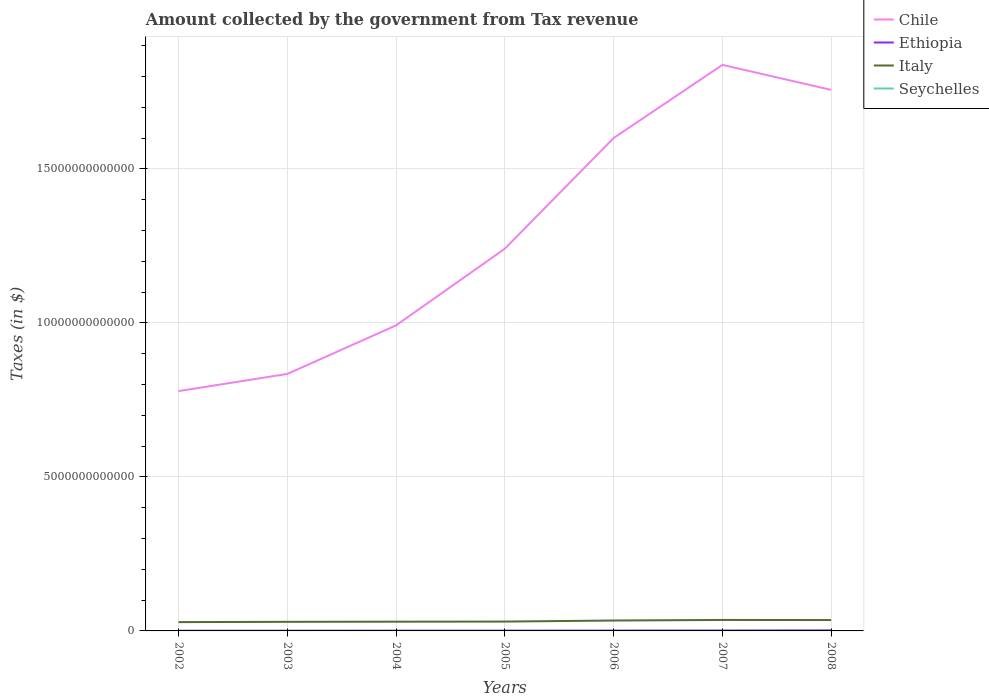How many different coloured lines are there?
Offer a terse response. 4. Does the line corresponding to Ethiopia intersect with the line corresponding to Chile?
Your response must be concise. No. Is the number of lines equal to the number of legend labels?
Provide a short and direct response. Yes. Across all years, what is the maximum amount collected by the government from tax revenue in Italy?
Your answer should be very brief. 2.86e+11. In which year was the amount collected by the government from tax revenue in Chile maximum?
Ensure brevity in your answer.  2002. What is the total amount collected by the government from tax revenue in Ethiopia in the graph?
Offer a terse response. -9.07e+08. What is the difference between the highest and the second highest amount collected by the government from tax revenue in Seychelles?
Provide a short and direct response. 1.05e+09. How many lines are there?
Provide a succinct answer. 4. How many years are there in the graph?
Make the answer very short. 7. What is the difference between two consecutive major ticks on the Y-axis?
Offer a very short reply. 5.00e+12. Are the values on the major ticks of Y-axis written in scientific E-notation?
Provide a short and direct response. No. Does the graph contain grids?
Make the answer very short. Yes. Where does the legend appear in the graph?
Your response must be concise. Top right. How are the legend labels stacked?
Your response must be concise. Vertical. What is the title of the graph?
Your response must be concise. Amount collected by the government from Tax revenue. What is the label or title of the Y-axis?
Keep it short and to the point. Taxes (in $). What is the Taxes (in $) in Chile in 2002?
Ensure brevity in your answer.  7.78e+12. What is the Taxes (in $) of Ethiopia in 2002?
Your answer should be compact. 6.51e+09. What is the Taxes (in $) in Italy in 2002?
Provide a succinct answer. 2.86e+11. What is the Taxes (in $) in Seychelles in 2002?
Make the answer very short. 9.99e+08. What is the Taxes (in $) in Chile in 2003?
Keep it short and to the point. 8.34e+12. What is the Taxes (in $) of Ethiopia in 2003?
Provide a succinct answer. 6.75e+09. What is the Taxes (in $) of Italy in 2003?
Your answer should be very brief. 2.95e+11. What is the Taxes (in $) in Seychelles in 2003?
Make the answer very short. 1.25e+09. What is the Taxes (in $) in Chile in 2004?
Keep it short and to the point. 9.92e+12. What is the Taxes (in $) in Ethiopia in 2004?
Offer a terse response. 8.45e+09. What is the Taxes (in $) of Italy in 2004?
Make the answer very short. 3.00e+11. What is the Taxes (in $) of Seychelles in 2004?
Make the answer very short. 1.36e+09. What is the Taxes (in $) of Chile in 2005?
Ensure brevity in your answer.  1.24e+13. What is the Taxes (in $) in Ethiopia in 2005?
Keep it short and to the point. 9.36e+09. What is the Taxes (in $) of Italy in 2005?
Offer a terse response. 3.03e+11. What is the Taxes (in $) in Seychelles in 2005?
Make the answer very short. 1.38e+09. What is the Taxes (in $) of Chile in 2006?
Provide a succinct answer. 1.60e+13. What is the Taxes (in $) in Ethiopia in 2006?
Your answer should be very brief. 1.10e+1. What is the Taxes (in $) of Italy in 2006?
Provide a short and direct response. 3.38e+11. What is the Taxes (in $) of Seychelles in 2006?
Your answer should be compact. 1.39e+09. What is the Taxes (in $) of Chile in 2007?
Provide a short and direct response. 1.84e+13. What is the Taxes (in $) of Ethiopia in 2007?
Ensure brevity in your answer.  1.35e+1. What is the Taxes (in $) of Italy in 2007?
Offer a terse response. 3.56e+11. What is the Taxes (in $) of Seychelles in 2007?
Offer a very short reply. 1.61e+09. What is the Taxes (in $) in Chile in 2008?
Keep it short and to the point. 1.76e+13. What is the Taxes (in $) of Ethiopia in 2008?
Offer a very short reply. 1.96e+1. What is the Taxes (in $) in Italy in 2008?
Your response must be concise. 3.53e+11. What is the Taxes (in $) in Seychelles in 2008?
Keep it short and to the point. 2.05e+09. Across all years, what is the maximum Taxes (in $) in Chile?
Your response must be concise. 1.84e+13. Across all years, what is the maximum Taxes (in $) of Ethiopia?
Provide a short and direct response. 1.96e+1. Across all years, what is the maximum Taxes (in $) in Italy?
Your answer should be compact. 3.56e+11. Across all years, what is the maximum Taxes (in $) in Seychelles?
Your answer should be compact. 2.05e+09. Across all years, what is the minimum Taxes (in $) in Chile?
Give a very brief answer. 7.78e+12. Across all years, what is the minimum Taxes (in $) of Ethiopia?
Give a very brief answer. 6.51e+09. Across all years, what is the minimum Taxes (in $) of Italy?
Offer a very short reply. 2.86e+11. Across all years, what is the minimum Taxes (in $) of Seychelles?
Your answer should be compact. 9.99e+08. What is the total Taxes (in $) of Chile in the graph?
Provide a short and direct response. 9.04e+13. What is the total Taxes (in $) in Ethiopia in the graph?
Your response must be concise. 7.51e+1. What is the total Taxes (in $) in Italy in the graph?
Make the answer very short. 2.23e+12. What is the total Taxes (in $) of Seychelles in the graph?
Ensure brevity in your answer.  1.00e+1. What is the difference between the Taxes (in $) in Chile in 2002 and that in 2003?
Offer a very short reply. -5.57e+11. What is the difference between the Taxes (in $) in Ethiopia in 2002 and that in 2003?
Offer a very short reply. -2.34e+08. What is the difference between the Taxes (in $) in Italy in 2002 and that in 2003?
Your answer should be compact. -9.16e+09. What is the difference between the Taxes (in $) of Seychelles in 2002 and that in 2003?
Give a very brief answer. -2.48e+08. What is the difference between the Taxes (in $) of Chile in 2002 and that in 2004?
Provide a short and direct response. -2.13e+12. What is the difference between the Taxes (in $) of Ethiopia in 2002 and that in 2004?
Your answer should be very brief. -1.94e+09. What is the difference between the Taxes (in $) of Italy in 2002 and that in 2004?
Your answer should be compact. -1.43e+1. What is the difference between the Taxes (in $) of Seychelles in 2002 and that in 2004?
Give a very brief answer. -3.63e+08. What is the difference between the Taxes (in $) in Chile in 2002 and that in 2005?
Ensure brevity in your answer.  -4.62e+12. What is the difference between the Taxes (in $) in Ethiopia in 2002 and that in 2005?
Your answer should be very brief. -2.85e+09. What is the difference between the Taxes (in $) in Italy in 2002 and that in 2005?
Provide a short and direct response. -1.72e+1. What is the difference between the Taxes (in $) of Seychelles in 2002 and that in 2005?
Your answer should be compact. -3.81e+08. What is the difference between the Taxes (in $) in Chile in 2002 and that in 2006?
Your answer should be very brief. -8.21e+12. What is the difference between the Taxes (in $) in Ethiopia in 2002 and that in 2006?
Provide a short and direct response. -4.45e+09. What is the difference between the Taxes (in $) of Italy in 2002 and that in 2006?
Give a very brief answer. -5.18e+1. What is the difference between the Taxes (in $) of Seychelles in 2002 and that in 2006?
Make the answer very short. -3.86e+08. What is the difference between the Taxes (in $) in Chile in 2002 and that in 2007?
Provide a short and direct response. -1.06e+13. What is the difference between the Taxes (in $) in Ethiopia in 2002 and that in 2007?
Provide a short and direct response. -7.03e+09. What is the difference between the Taxes (in $) in Italy in 2002 and that in 2007?
Provide a short and direct response. -7.00e+1. What is the difference between the Taxes (in $) of Seychelles in 2002 and that in 2007?
Provide a succinct answer. -6.11e+08. What is the difference between the Taxes (in $) of Chile in 2002 and that in 2008?
Your answer should be compact. -9.78e+12. What is the difference between the Taxes (in $) in Ethiopia in 2002 and that in 2008?
Keep it short and to the point. -1.30e+1. What is the difference between the Taxes (in $) of Italy in 2002 and that in 2008?
Provide a short and direct response. -6.68e+1. What is the difference between the Taxes (in $) of Seychelles in 2002 and that in 2008?
Ensure brevity in your answer.  -1.05e+09. What is the difference between the Taxes (in $) of Chile in 2003 and that in 2004?
Your answer should be compact. -1.58e+12. What is the difference between the Taxes (in $) in Ethiopia in 2003 and that in 2004?
Give a very brief answer. -1.71e+09. What is the difference between the Taxes (in $) in Italy in 2003 and that in 2004?
Provide a succinct answer. -5.10e+09. What is the difference between the Taxes (in $) in Seychelles in 2003 and that in 2004?
Keep it short and to the point. -1.15e+08. What is the difference between the Taxes (in $) of Chile in 2003 and that in 2005?
Your answer should be very brief. -4.07e+12. What is the difference between the Taxes (in $) in Ethiopia in 2003 and that in 2005?
Offer a terse response. -2.61e+09. What is the difference between the Taxes (in $) in Italy in 2003 and that in 2005?
Make the answer very short. -8.04e+09. What is the difference between the Taxes (in $) in Seychelles in 2003 and that in 2005?
Keep it short and to the point. -1.33e+08. What is the difference between the Taxes (in $) of Chile in 2003 and that in 2006?
Make the answer very short. -7.66e+12. What is the difference between the Taxes (in $) of Ethiopia in 2003 and that in 2006?
Provide a succinct answer. -4.21e+09. What is the difference between the Taxes (in $) in Italy in 2003 and that in 2006?
Provide a succinct answer. -4.26e+1. What is the difference between the Taxes (in $) in Seychelles in 2003 and that in 2006?
Provide a succinct answer. -1.38e+08. What is the difference between the Taxes (in $) in Chile in 2003 and that in 2007?
Your answer should be very brief. -1.00e+13. What is the difference between the Taxes (in $) of Ethiopia in 2003 and that in 2007?
Make the answer very short. -6.79e+09. What is the difference between the Taxes (in $) in Italy in 2003 and that in 2007?
Your answer should be compact. -6.08e+1. What is the difference between the Taxes (in $) in Seychelles in 2003 and that in 2007?
Ensure brevity in your answer.  -3.63e+08. What is the difference between the Taxes (in $) of Chile in 2003 and that in 2008?
Keep it short and to the point. -9.22e+12. What is the difference between the Taxes (in $) in Ethiopia in 2003 and that in 2008?
Your answer should be very brief. -1.28e+1. What is the difference between the Taxes (in $) in Italy in 2003 and that in 2008?
Your response must be concise. -5.76e+1. What is the difference between the Taxes (in $) of Seychelles in 2003 and that in 2008?
Your answer should be compact. -7.99e+08. What is the difference between the Taxes (in $) in Chile in 2004 and that in 2005?
Provide a succinct answer. -2.49e+12. What is the difference between the Taxes (in $) of Ethiopia in 2004 and that in 2005?
Offer a terse response. -9.07e+08. What is the difference between the Taxes (in $) in Italy in 2004 and that in 2005?
Provide a short and direct response. -2.94e+09. What is the difference between the Taxes (in $) of Seychelles in 2004 and that in 2005?
Offer a terse response. -1.75e+07. What is the difference between the Taxes (in $) of Chile in 2004 and that in 2006?
Your answer should be compact. -6.08e+12. What is the difference between the Taxes (in $) of Ethiopia in 2004 and that in 2006?
Your answer should be very brief. -2.51e+09. What is the difference between the Taxes (in $) of Italy in 2004 and that in 2006?
Give a very brief answer. -3.75e+1. What is the difference between the Taxes (in $) of Seychelles in 2004 and that in 2006?
Provide a short and direct response. -2.28e+07. What is the difference between the Taxes (in $) in Chile in 2004 and that in 2007?
Provide a succinct answer. -8.45e+12. What is the difference between the Taxes (in $) in Ethiopia in 2004 and that in 2007?
Keep it short and to the point. -5.09e+09. What is the difference between the Taxes (in $) in Italy in 2004 and that in 2007?
Keep it short and to the point. -5.57e+1. What is the difference between the Taxes (in $) of Seychelles in 2004 and that in 2007?
Offer a very short reply. -2.48e+08. What is the difference between the Taxes (in $) in Chile in 2004 and that in 2008?
Give a very brief answer. -7.64e+12. What is the difference between the Taxes (in $) of Ethiopia in 2004 and that in 2008?
Your answer should be very brief. -1.11e+1. What is the difference between the Taxes (in $) in Italy in 2004 and that in 2008?
Provide a short and direct response. -5.25e+1. What is the difference between the Taxes (in $) of Seychelles in 2004 and that in 2008?
Provide a short and direct response. -6.83e+08. What is the difference between the Taxes (in $) of Chile in 2005 and that in 2006?
Give a very brief answer. -3.59e+12. What is the difference between the Taxes (in $) of Ethiopia in 2005 and that in 2006?
Give a very brief answer. -1.60e+09. What is the difference between the Taxes (in $) of Italy in 2005 and that in 2006?
Make the answer very short. -3.46e+1. What is the difference between the Taxes (in $) in Seychelles in 2005 and that in 2006?
Your answer should be compact. -5.30e+06. What is the difference between the Taxes (in $) of Chile in 2005 and that in 2007?
Make the answer very short. -5.97e+12. What is the difference between the Taxes (in $) of Ethiopia in 2005 and that in 2007?
Ensure brevity in your answer.  -4.18e+09. What is the difference between the Taxes (in $) of Italy in 2005 and that in 2007?
Your answer should be very brief. -5.28e+1. What is the difference between the Taxes (in $) of Seychelles in 2005 and that in 2007?
Your answer should be very brief. -2.30e+08. What is the difference between the Taxes (in $) of Chile in 2005 and that in 2008?
Your answer should be compact. -5.15e+12. What is the difference between the Taxes (in $) in Ethiopia in 2005 and that in 2008?
Your answer should be very brief. -1.02e+1. What is the difference between the Taxes (in $) of Italy in 2005 and that in 2008?
Provide a short and direct response. -4.96e+1. What is the difference between the Taxes (in $) in Seychelles in 2005 and that in 2008?
Your answer should be compact. -6.66e+08. What is the difference between the Taxes (in $) of Chile in 2006 and that in 2007?
Provide a short and direct response. -2.37e+12. What is the difference between the Taxes (in $) in Ethiopia in 2006 and that in 2007?
Make the answer very short. -2.58e+09. What is the difference between the Taxes (in $) of Italy in 2006 and that in 2007?
Offer a terse response. -1.82e+1. What is the difference between the Taxes (in $) of Seychelles in 2006 and that in 2007?
Offer a terse response. -2.25e+08. What is the difference between the Taxes (in $) in Chile in 2006 and that in 2008?
Provide a short and direct response. -1.56e+12. What is the difference between the Taxes (in $) of Ethiopia in 2006 and that in 2008?
Ensure brevity in your answer.  -8.59e+09. What is the difference between the Taxes (in $) in Italy in 2006 and that in 2008?
Make the answer very short. -1.50e+1. What is the difference between the Taxes (in $) of Seychelles in 2006 and that in 2008?
Ensure brevity in your answer.  -6.61e+08. What is the difference between the Taxes (in $) of Chile in 2007 and that in 2008?
Your answer should be compact. 8.12e+11. What is the difference between the Taxes (in $) of Ethiopia in 2007 and that in 2008?
Your answer should be very brief. -6.01e+09. What is the difference between the Taxes (in $) of Italy in 2007 and that in 2008?
Keep it short and to the point. 3.18e+09. What is the difference between the Taxes (in $) in Seychelles in 2007 and that in 2008?
Your answer should be very brief. -4.36e+08. What is the difference between the Taxes (in $) in Chile in 2002 and the Taxes (in $) in Ethiopia in 2003?
Provide a short and direct response. 7.78e+12. What is the difference between the Taxes (in $) of Chile in 2002 and the Taxes (in $) of Italy in 2003?
Your answer should be very brief. 7.49e+12. What is the difference between the Taxes (in $) of Chile in 2002 and the Taxes (in $) of Seychelles in 2003?
Keep it short and to the point. 7.78e+12. What is the difference between the Taxes (in $) in Ethiopia in 2002 and the Taxes (in $) in Italy in 2003?
Your response must be concise. -2.89e+11. What is the difference between the Taxes (in $) in Ethiopia in 2002 and the Taxes (in $) in Seychelles in 2003?
Offer a terse response. 5.26e+09. What is the difference between the Taxes (in $) in Italy in 2002 and the Taxes (in $) in Seychelles in 2003?
Offer a terse response. 2.85e+11. What is the difference between the Taxes (in $) of Chile in 2002 and the Taxes (in $) of Ethiopia in 2004?
Make the answer very short. 7.78e+12. What is the difference between the Taxes (in $) of Chile in 2002 and the Taxes (in $) of Italy in 2004?
Provide a succinct answer. 7.48e+12. What is the difference between the Taxes (in $) in Chile in 2002 and the Taxes (in $) in Seychelles in 2004?
Your response must be concise. 7.78e+12. What is the difference between the Taxes (in $) in Ethiopia in 2002 and the Taxes (in $) in Italy in 2004?
Your answer should be very brief. -2.94e+11. What is the difference between the Taxes (in $) in Ethiopia in 2002 and the Taxes (in $) in Seychelles in 2004?
Provide a succinct answer. 5.15e+09. What is the difference between the Taxes (in $) in Italy in 2002 and the Taxes (in $) in Seychelles in 2004?
Keep it short and to the point. 2.85e+11. What is the difference between the Taxes (in $) in Chile in 2002 and the Taxes (in $) in Ethiopia in 2005?
Ensure brevity in your answer.  7.77e+12. What is the difference between the Taxes (in $) of Chile in 2002 and the Taxes (in $) of Italy in 2005?
Your answer should be compact. 7.48e+12. What is the difference between the Taxes (in $) in Chile in 2002 and the Taxes (in $) in Seychelles in 2005?
Your answer should be compact. 7.78e+12. What is the difference between the Taxes (in $) of Ethiopia in 2002 and the Taxes (in $) of Italy in 2005?
Provide a short and direct response. -2.97e+11. What is the difference between the Taxes (in $) in Ethiopia in 2002 and the Taxes (in $) in Seychelles in 2005?
Your answer should be very brief. 5.13e+09. What is the difference between the Taxes (in $) in Italy in 2002 and the Taxes (in $) in Seychelles in 2005?
Ensure brevity in your answer.  2.85e+11. What is the difference between the Taxes (in $) in Chile in 2002 and the Taxes (in $) in Ethiopia in 2006?
Keep it short and to the point. 7.77e+12. What is the difference between the Taxes (in $) of Chile in 2002 and the Taxes (in $) of Italy in 2006?
Make the answer very short. 7.45e+12. What is the difference between the Taxes (in $) of Chile in 2002 and the Taxes (in $) of Seychelles in 2006?
Give a very brief answer. 7.78e+12. What is the difference between the Taxes (in $) in Ethiopia in 2002 and the Taxes (in $) in Italy in 2006?
Offer a terse response. -3.31e+11. What is the difference between the Taxes (in $) of Ethiopia in 2002 and the Taxes (in $) of Seychelles in 2006?
Offer a terse response. 5.13e+09. What is the difference between the Taxes (in $) in Italy in 2002 and the Taxes (in $) in Seychelles in 2006?
Offer a terse response. 2.85e+11. What is the difference between the Taxes (in $) of Chile in 2002 and the Taxes (in $) of Ethiopia in 2007?
Offer a very short reply. 7.77e+12. What is the difference between the Taxes (in $) in Chile in 2002 and the Taxes (in $) in Italy in 2007?
Offer a terse response. 7.43e+12. What is the difference between the Taxes (in $) of Chile in 2002 and the Taxes (in $) of Seychelles in 2007?
Provide a succinct answer. 7.78e+12. What is the difference between the Taxes (in $) in Ethiopia in 2002 and the Taxes (in $) in Italy in 2007?
Make the answer very short. -3.49e+11. What is the difference between the Taxes (in $) of Ethiopia in 2002 and the Taxes (in $) of Seychelles in 2007?
Your answer should be very brief. 4.90e+09. What is the difference between the Taxes (in $) in Italy in 2002 and the Taxes (in $) in Seychelles in 2007?
Your response must be concise. 2.84e+11. What is the difference between the Taxes (in $) in Chile in 2002 and the Taxes (in $) in Ethiopia in 2008?
Your response must be concise. 7.76e+12. What is the difference between the Taxes (in $) in Chile in 2002 and the Taxes (in $) in Italy in 2008?
Give a very brief answer. 7.43e+12. What is the difference between the Taxes (in $) in Chile in 2002 and the Taxes (in $) in Seychelles in 2008?
Offer a very short reply. 7.78e+12. What is the difference between the Taxes (in $) in Ethiopia in 2002 and the Taxes (in $) in Italy in 2008?
Make the answer very short. -3.46e+11. What is the difference between the Taxes (in $) in Ethiopia in 2002 and the Taxes (in $) in Seychelles in 2008?
Your answer should be very brief. 4.47e+09. What is the difference between the Taxes (in $) in Italy in 2002 and the Taxes (in $) in Seychelles in 2008?
Offer a very short reply. 2.84e+11. What is the difference between the Taxes (in $) in Chile in 2003 and the Taxes (in $) in Ethiopia in 2004?
Your response must be concise. 8.33e+12. What is the difference between the Taxes (in $) of Chile in 2003 and the Taxes (in $) of Italy in 2004?
Provide a succinct answer. 8.04e+12. What is the difference between the Taxes (in $) of Chile in 2003 and the Taxes (in $) of Seychelles in 2004?
Give a very brief answer. 8.34e+12. What is the difference between the Taxes (in $) of Ethiopia in 2003 and the Taxes (in $) of Italy in 2004?
Provide a succinct answer. -2.93e+11. What is the difference between the Taxes (in $) of Ethiopia in 2003 and the Taxes (in $) of Seychelles in 2004?
Ensure brevity in your answer.  5.38e+09. What is the difference between the Taxes (in $) in Italy in 2003 and the Taxes (in $) in Seychelles in 2004?
Your answer should be very brief. 2.94e+11. What is the difference between the Taxes (in $) in Chile in 2003 and the Taxes (in $) in Ethiopia in 2005?
Make the answer very short. 8.33e+12. What is the difference between the Taxes (in $) of Chile in 2003 and the Taxes (in $) of Italy in 2005?
Make the answer very short. 8.04e+12. What is the difference between the Taxes (in $) of Chile in 2003 and the Taxes (in $) of Seychelles in 2005?
Provide a succinct answer. 8.34e+12. What is the difference between the Taxes (in $) of Ethiopia in 2003 and the Taxes (in $) of Italy in 2005?
Ensure brevity in your answer.  -2.96e+11. What is the difference between the Taxes (in $) in Ethiopia in 2003 and the Taxes (in $) in Seychelles in 2005?
Your answer should be very brief. 5.37e+09. What is the difference between the Taxes (in $) in Italy in 2003 and the Taxes (in $) in Seychelles in 2005?
Keep it short and to the point. 2.94e+11. What is the difference between the Taxes (in $) in Chile in 2003 and the Taxes (in $) in Ethiopia in 2006?
Provide a succinct answer. 8.33e+12. What is the difference between the Taxes (in $) of Chile in 2003 and the Taxes (in $) of Italy in 2006?
Provide a succinct answer. 8.00e+12. What is the difference between the Taxes (in $) in Chile in 2003 and the Taxes (in $) in Seychelles in 2006?
Provide a succinct answer. 8.34e+12. What is the difference between the Taxes (in $) in Ethiopia in 2003 and the Taxes (in $) in Italy in 2006?
Keep it short and to the point. -3.31e+11. What is the difference between the Taxes (in $) of Ethiopia in 2003 and the Taxes (in $) of Seychelles in 2006?
Provide a short and direct response. 5.36e+09. What is the difference between the Taxes (in $) of Italy in 2003 and the Taxes (in $) of Seychelles in 2006?
Provide a short and direct response. 2.94e+11. What is the difference between the Taxes (in $) in Chile in 2003 and the Taxes (in $) in Ethiopia in 2007?
Provide a succinct answer. 8.33e+12. What is the difference between the Taxes (in $) of Chile in 2003 and the Taxes (in $) of Italy in 2007?
Offer a very short reply. 7.99e+12. What is the difference between the Taxes (in $) in Chile in 2003 and the Taxes (in $) in Seychelles in 2007?
Offer a very short reply. 8.34e+12. What is the difference between the Taxes (in $) in Ethiopia in 2003 and the Taxes (in $) in Italy in 2007?
Your response must be concise. -3.49e+11. What is the difference between the Taxes (in $) in Ethiopia in 2003 and the Taxes (in $) in Seychelles in 2007?
Keep it short and to the point. 5.14e+09. What is the difference between the Taxes (in $) in Italy in 2003 and the Taxes (in $) in Seychelles in 2007?
Give a very brief answer. 2.94e+11. What is the difference between the Taxes (in $) in Chile in 2003 and the Taxes (in $) in Ethiopia in 2008?
Keep it short and to the point. 8.32e+12. What is the difference between the Taxes (in $) in Chile in 2003 and the Taxes (in $) in Italy in 2008?
Your answer should be very brief. 7.99e+12. What is the difference between the Taxes (in $) in Chile in 2003 and the Taxes (in $) in Seychelles in 2008?
Make the answer very short. 8.34e+12. What is the difference between the Taxes (in $) of Ethiopia in 2003 and the Taxes (in $) of Italy in 2008?
Offer a very short reply. -3.46e+11. What is the difference between the Taxes (in $) of Ethiopia in 2003 and the Taxes (in $) of Seychelles in 2008?
Make the answer very short. 4.70e+09. What is the difference between the Taxes (in $) in Italy in 2003 and the Taxes (in $) in Seychelles in 2008?
Offer a very short reply. 2.93e+11. What is the difference between the Taxes (in $) of Chile in 2004 and the Taxes (in $) of Ethiopia in 2005?
Offer a terse response. 9.91e+12. What is the difference between the Taxes (in $) of Chile in 2004 and the Taxes (in $) of Italy in 2005?
Ensure brevity in your answer.  9.62e+12. What is the difference between the Taxes (in $) in Chile in 2004 and the Taxes (in $) in Seychelles in 2005?
Ensure brevity in your answer.  9.92e+12. What is the difference between the Taxes (in $) of Ethiopia in 2004 and the Taxes (in $) of Italy in 2005?
Provide a short and direct response. -2.95e+11. What is the difference between the Taxes (in $) in Ethiopia in 2004 and the Taxes (in $) in Seychelles in 2005?
Your answer should be very brief. 7.07e+09. What is the difference between the Taxes (in $) of Italy in 2004 and the Taxes (in $) of Seychelles in 2005?
Your answer should be compact. 2.99e+11. What is the difference between the Taxes (in $) in Chile in 2004 and the Taxes (in $) in Ethiopia in 2006?
Ensure brevity in your answer.  9.91e+12. What is the difference between the Taxes (in $) in Chile in 2004 and the Taxes (in $) in Italy in 2006?
Your response must be concise. 9.58e+12. What is the difference between the Taxes (in $) in Chile in 2004 and the Taxes (in $) in Seychelles in 2006?
Offer a very short reply. 9.92e+12. What is the difference between the Taxes (in $) in Ethiopia in 2004 and the Taxes (in $) in Italy in 2006?
Offer a very short reply. -3.29e+11. What is the difference between the Taxes (in $) of Ethiopia in 2004 and the Taxes (in $) of Seychelles in 2006?
Your response must be concise. 7.07e+09. What is the difference between the Taxes (in $) in Italy in 2004 and the Taxes (in $) in Seychelles in 2006?
Your answer should be very brief. 2.99e+11. What is the difference between the Taxes (in $) in Chile in 2004 and the Taxes (in $) in Ethiopia in 2007?
Your answer should be compact. 9.91e+12. What is the difference between the Taxes (in $) in Chile in 2004 and the Taxes (in $) in Italy in 2007?
Your response must be concise. 9.56e+12. What is the difference between the Taxes (in $) in Chile in 2004 and the Taxes (in $) in Seychelles in 2007?
Make the answer very short. 9.92e+12. What is the difference between the Taxes (in $) of Ethiopia in 2004 and the Taxes (in $) of Italy in 2007?
Offer a very short reply. -3.47e+11. What is the difference between the Taxes (in $) in Ethiopia in 2004 and the Taxes (in $) in Seychelles in 2007?
Offer a very short reply. 6.84e+09. What is the difference between the Taxes (in $) in Italy in 2004 and the Taxes (in $) in Seychelles in 2007?
Keep it short and to the point. 2.99e+11. What is the difference between the Taxes (in $) of Chile in 2004 and the Taxes (in $) of Ethiopia in 2008?
Give a very brief answer. 9.90e+12. What is the difference between the Taxes (in $) of Chile in 2004 and the Taxes (in $) of Italy in 2008?
Your response must be concise. 9.57e+12. What is the difference between the Taxes (in $) in Chile in 2004 and the Taxes (in $) in Seychelles in 2008?
Give a very brief answer. 9.92e+12. What is the difference between the Taxes (in $) of Ethiopia in 2004 and the Taxes (in $) of Italy in 2008?
Ensure brevity in your answer.  -3.44e+11. What is the difference between the Taxes (in $) in Ethiopia in 2004 and the Taxes (in $) in Seychelles in 2008?
Offer a very short reply. 6.41e+09. What is the difference between the Taxes (in $) in Italy in 2004 and the Taxes (in $) in Seychelles in 2008?
Offer a very short reply. 2.98e+11. What is the difference between the Taxes (in $) in Chile in 2005 and the Taxes (in $) in Ethiopia in 2006?
Your answer should be very brief. 1.24e+13. What is the difference between the Taxes (in $) of Chile in 2005 and the Taxes (in $) of Italy in 2006?
Provide a short and direct response. 1.21e+13. What is the difference between the Taxes (in $) in Chile in 2005 and the Taxes (in $) in Seychelles in 2006?
Your answer should be compact. 1.24e+13. What is the difference between the Taxes (in $) of Ethiopia in 2005 and the Taxes (in $) of Italy in 2006?
Ensure brevity in your answer.  -3.28e+11. What is the difference between the Taxes (in $) in Ethiopia in 2005 and the Taxes (in $) in Seychelles in 2006?
Your answer should be very brief. 7.98e+09. What is the difference between the Taxes (in $) in Italy in 2005 and the Taxes (in $) in Seychelles in 2006?
Keep it short and to the point. 3.02e+11. What is the difference between the Taxes (in $) in Chile in 2005 and the Taxes (in $) in Ethiopia in 2007?
Your response must be concise. 1.24e+13. What is the difference between the Taxes (in $) in Chile in 2005 and the Taxes (in $) in Italy in 2007?
Make the answer very short. 1.21e+13. What is the difference between the Taxes (in $) in Chile in 2005 and the Taxes (in $) in Seychelles in 2007?
Your answer should be compact. 1.24e+13. What is the difference between the Taxes (in $) in Ethiopia in 2005 and the Taxes (in $) in Italy in 2007?
Provide a short and direct response. -3.47e+11. What is the difference between the Taxes (in $) in Ethiopia in 2005 and the Taxes (in $) in Seychelles in 2007?
Your response must be concise. 7.75e+09. What is the difference between the Taxes (in $) in Italy in 2005 and the Taxes (in $) in Seychelles in 2007?
Ensure brevity in your answer.  3.02e+11. What is the difference between the Taxes (in $) of Chile in 2005 and the Taxes (in $) of Ethiopia in 2008?
Ensure brevity in your answer.  1.24e+13. What is the difference between the Taxes (in $) in Chile in 2005 and the Taxes (in $) in Italy in 2008?
Provide a succinct answer. 1.21e+13. What is the difference between the Taxes (in $) in Chile in 2005 and the Taxes (in $) in Seychelles in 2008?
Your answer should be compact. 1.24e+13. What is the difference between the Taxes (in $) of Ethiopia in 2005 and the Taxes (in $) of Italy in 2008?
Offer a terse response. -3.43e+11. What is the difference between the Taxes (in $) in Ethiopia in 2005 and the Taxes (in $) in Seychelles in 2008?
Your answer should be compact. 7.31e+09. What is the difference between the Taxes (in $) of Italy in 2005 and the Taxes (in $) of Seychelles in 2008?
Your answer should be compact. 3.01e+11. What is the difference between the Taxes (in $) in Chile in 2006 and the Taxes (in $) in Ethiopia in 2007?
Your answer should be compact. 1.60e+13. What is the difference between the Taxes (in $) of Chile in 2006 and the Taxes (in $) of Italy in 2007?
Offer a terse response. 1.56e+13. What is the difference between the Taxes (in $) of Chile in 2006 and the Taxes (in $) of Seychelles in 2007?
Your answer should be compact. 1.60e+13. What is the difference between the Taxes (in $) in Ethiopia in 2006 and the Taxes (in $) in Italy in 2007?
Your answer should be compact. -3.45e+11. What is the difference between the Taxes (in $) of Ethiopia in 2006 and the Taxes (in $) of Seychelles in 2007?
Offer a terse response. 9.35e+09. What is the difference between the Taxes (in $) in Italy in 2006 and the Taxes (in $) in Seychelles in 2007?
Your answer should be very brief. 3.36e+11. What is the difference between the Taxes (in $) in Chile in 2006 and the Taxes (in $) in Ethiopia in 2008?
Give a very brief answer. 1.60e+13. What is the difference between the Taxes (in $) in Chile in 2006 and the Taxes (in $) in Italy in 2008?
Ensure brevity in your answer.  1.56e+13. What is the difference between the Taxes (in $) in Chile in 2006 and the Taxes (in $) in Seychelles in 2008?
Your answer should be compact. 1.60e+13. What is the difference between the Taxes (in $) in Ethiopia in 2006 and the Taxes (in $) in Italy in 2008?
Keep it short and to the point. -3.42e+11. What is the difference between the Taxes (in $) of Ethiopia in 2006 and the Taxes (in $) of Seychelles in 2008?
Provide a succinct answer. 8.91e+09. What is the difference between the Taxes (in $) in Italy in 2006 and the Taxes (in $) in Seychelles in 2008?
Ensure brevity in your answer.  3.36e+11. What is the difference between the Taxes (in $) of Chile in 2007 and the Taxes (in $) of Ethiopia in 2008?
Your response must be concise. 1.84e+13. What is the difference between the Taxes (in $) of Chile in 2007 and the Taxes (in $) of Italy in 2008?
Keep it short and to the point. 1.80e+13. What is the difference between the Taxes (in $) in Chile in 2007 and the Taxes (in $) in Seychelles in 2008?
Ensure brevity in your answer.  1.84e+13. What is the difference between the Taxes (in $) of Ethiopia in 2007 and the Taxes (in $) of Italy in 2008?
Offer a terse response. -3.39e+11. What is the difference between the Taxes (in $) of Ethiopia in 2007 and the Taxes (in $) of Seychelles in 2008?
Make the answer very short. 1.15e+1. What is the difference between the Taxes (in $) in Italy in 2007 and the Taxes (in $) in Seychelles in 2008?
Your response must be concise. 3.54e+11. What is the average Taxes (in $) of Chile per year?
Ensure brevity in your answer.  1.29e+13. What is the average Taxes (in $) of Ethiopia per year?
Offer a terse response. 1.07e+1. What is the average Taxes (in $) in Italy per year?
Ensure brevity in your answer.  3.19e+11. What is the average Taxes (in $) in Seychelles per year?
Keep it short and to the point. 1.43e+09. In the year 2002, what is the difference between the Taxes (in $) in Chile and Taxes (in $) in Ethiopia?
Offer a very short reply. 7.78e+12. In the year 2002, what is the difference between the Taxes (in $) in Chile and Taxes (in $) in Italy?
Your response must be concise. 7.50e+12. In the year 2002, what is the difference between the Taxes (in $) in Chile and Taxes (in $) in Seychelles?
Your response must be concise. 7.78e+12. In the year 2002, what is the difference between the Taxes (in $) in Ethiopia and Taxes (in $) in Italy?
Your answer should be compact. -2.79e+11. In the year 2002, what is the difference between the Taxes (in $) in Ethiopia and Taxes (in $) in Seychelles?
Provide a succinct answer. 5.51e+09. In the year 2002, what is the difference between the Taxes (in $) in Italy and Taxes (in $) in Seychelles?
Provide a short and direct response. 2.85e+11. In the year 2003, what is the difference between the Taxes (in $) of Chile and Taxes (in $) of Ethiopia?
Provide a short and direct response. 8.33e+12. In the year 2003, what is the difference between the Taxes (in $) in Chile and Taxes (in $) in Italy?
Offer a very short reply. 8.05e+12. In the year 2003, what is the difference between the Taxes (in $) of Chile and Taxes (in $) of Seychelles?
Offer a terse response. 8.34e+12. In the year 2003, what is the difference between the Taxes (in $) in Ethiopia and Taxes (in $) in Italy?
Your response must be concise. -2.88e+11. In the year 2003, what is the difference between the Taxes (in $) in Ethiopia and Taxes (in $) in Seychelles?
Offer a terse response. 5.50e+09. In the year 2003, what is the difference between the Taxes (in $) of Italy and Taxes (in $) of Seychelles?
Provide a succinct answer. 2.94e+11. In the year 2004, what is the difference between the Taxes (in $) in Chile and Taxes (in $) in Ethiopia?
Provide a succinct answer. 9.91e+12. In the year 2004, what is the difference between the Taxes (in $) in Chile and Taxes (in $) in Italy?
Offer a terse response. 9.62e+12. In the year 2004, what is the difference between the Taxes (in $) of Chile and Taxes (in $) of Seychelles?
Keep it short and to the point. 9.92e+12. In the year 2004, what is the difference between the Taxes (in $) in Ethiopia and Taxes (in $) in Italy?
Your answer should be compact. -2.92e+11. In the year 2004, what is the difference between the Taxes (in $) of Ethiopia and Taxes (in $) of Seychelles?
Provide a short and direct response. 7.09e+09. In the year 2004, what is the difference between the Taxes (in $) in Italy and Taxes (in $) in Seychelles?
Your answer should be very brief. 2.99e+11. In the year 2005, what is the difference between the Taxes (in $) of Chile and Taxes (in $) of Ethiopia?
Offer a terse response. 1.24e+13. In the year 2005, what is the difference between the Taxes (in $) in Chile and Taxes (in $) in Italy?
Give a very brief answer. 1.21e+13. In the year 2005, what is the difference between the Taxes (in $) of Chile and Taxes (in $) of Seychelles?
Your answer should be very brief. 1.24e+13. In the year 2005, what is the difference between the Taxes (in $) of Ethiopia and Taxes (in $) of Italy?
Your answer should be compact. -2.94e+11. In the year 2005, what is the difference between the Taxes (in $) of Ethiopia and Taxes (in $) of Seychelles?
Offer a very short reply. 7.98e+09. In the year 2005, what is the difference between the Taxes (in $) in Italy and Taxes (in $) in Seychelles?
Give a very brief answer. 3.02e+11. In the year 2006, what is the difference between the Taxes (in $) in Chile and Taxes (in $) in Ethiopia?
Your answer should be compact. 1.60e+13. In the year 2006, what is the difference between the Taxes (in $) of Chile and Taxes (in $) of Italy?
Your answer should be very brief. 1.57e+13. In the year 2006, what is the difference between the Taxes (in $) of Chile and Taxes (in $) of Seychelles?
Your response must be concise. 1.60e+13. In the year 2006, what is the difference between the Taxes (in $) in Ethiopia and Taxes (in $) in Italy?
Your answer should be compact. -3.27e+11. In the year 2006, what is the difference between the Taxes (in $) of Ethiopia and Taxes (in $) of Seychelles?
Offer a very short reply. 9.58e+09. In the year 2006, what is the difference between the Taxes (in $) in Italy and Taxes (in $) in Seychelles?
Your answer should be compact. 3.36e+11. In the year 2007, what is the difference between the Taxes (in $) in Chile and Taxes (in $) in Ethiopia?
Your answer should be compact. 1.84e+13. In the year 2007, what is the difference between the Taxes (in $) of Chile and Taxes (in $) of Italy?
Offer a very short reply. 1.80e+13. In the year 2007, what is the difference between the Taxes (in $) in Chile and Taxes (in $) in Seychelles?
Ensure brevity in your answer.  1.84e+13. In the year 2007, what is the difference between the Taxes (in $) in Ethiopia and Taxes (in $) in Italy?
Ensure brevity in your answer.  -3.42e+11. In the year 2007, what is the difference between the Taxes (in $) in Ethiopia and Taxes (in $) in Seychelles?
Keep it short and to the point. 1.19e+1. In the year 2007, what is the difference between the Taxes (in $) in Italy and Taxes (in $) in Seychelles?
Make the answer very short. 3.54e+11. In the year 2008, what is the difference between the Taxes (in $) of Chile and Taxes (in $) of Ethiopia?
Offer a terse response. 1.75e+13. In the year 2008, what is the difference between the Taxes (in $) in Chile and Taxes (in $) in Italy?
Your response must be concise. 1.72e+13. In the year 2008, what is the difference between the Taxes (in $) in Chile and Taxes (in $) in Seychelles?
Offer a terse response. 1.76e+13. In the year 2008, what is the difference between the Taxes (in $) in Ethiopia and Taxes (in $) in Italy?
Your answer should be very brief. -3.33e+11. In the year 2008, what is the difference between the Taxes (in $) in Ethiopia and Taxes (in $) in Seychelles?
Your answer should be very brief. 1.75e+1. In the year 2008, what is the difference between the Taxes (in $) of Italy and Taxes (in $) of Seychelles?
Provide a succinct answer. 3.51e+11. What is the ratio of the Taxes (in $) in Chile in 2002 to that in 2003?
Provide a succinct answer. 0.93. What is the ratio of the Taxes (in $) of Ethiopia in 2002 to that in 2003?
Provide a short and direct response. 0.97. What is the ratio of the Taxes (in $) of Italy in 2002 to that in 2003?
Give a very brief answer. 0.97. What is the ratio of the Taxes (in $) in Seychelles in 2002 to that in 2003?
Offer a very short reply. 0.8. What is the ratio of the Taxes (in $) in Chile in 2002 to that in 2004?
Give a very brief answer. 0.78. What is the ratio of the Taxes (in $) in Ethiopia in 2002 to that in 2004?
Your answer should be compact. 0.77. What is the ratio of the Taxes (in $) in Italy in 2002 to that in 2004?
Offer a terse response. 0.95. What is the ratio of the Taxes (in $) in Seychelles in 2002 to that in 2004?
Your response must be concise. 0.73. What is the ratio of the Taxes (in $) of Chile in 2002 to that in 2005?
Provide a short and direct response. 0.63. What is the ratio of the Taxes (in $) of Ethiopia in 2002 to that in 2005?
Provide a short and direct response. 0.7. What is the ratio of the Taxes (in $) of Italy in 2002 to that in 2005?
Provide a succinct answer. 0.94. What is the ratio of the Taxes (in $) in Seychelles in 2002 to that in 2005?
Offer a terse response. 0.72. What is the ratio of the Taxes (in $) in Chile in 2002 to that in 2006?
Your response must be concise. 0.49. What is the ratio of the Taxes (in $) of Ethiopia in 2002 to that in 2006?
Your answer should be compact. 0.59. What is the ratio of the Taxes (in $) of Italy in 2002 to that in 2006?
Your answer should be very brief. 0.85. What is the ratio of the Taxes (in $) in Seychelles in 2002 to that in 2006?
Make the answer very short. 0.72. What is the ratio of the Taxes (in $) of Chile in 2002 to that in 2007?
Offer a very short reply. 0.42. What is the ratio of the Taxes (in $) of Ethiopia in 2002 to that in 2007?
Offer a very short reply. 0.48. What is the ratio of the Taxes (in $) of Italy in 2002 to that in 2007?
Your answer should be compact. 0.8. What is the ratio of the Taxes (in $) of Seychelles in 2002 to that in 2007?
Provide a short and direct response. 0.62. What is the ratio of the Taxes (in $) of Chile in 2002 to that in 2008?
Ensure brevity in your answer.  0.44. What is the ratio of the Taxes (in $) of Ethiopia in 2002 to that in 2008?
Offer a very short reply. 0.33. What is the ratio of the Taxes (in $) of Italy in 2002 to that in 2008?
Offer a terse response. 0.81. What is the ratio of the Taxes (in $) of Seychelles in 2002 to that in 2008?
Provide a short and direct response. 0.49. What is the ratio of the Taxes (in $) in Chile in 2003 to that in 2004?
Your answer should be compact. 0.84. What is the ratio of the Taxes (in $) of Ethiopia in 2003 to that in 2004?
Provide a short and direct response. 0.8. What is the ratio of the Taxes (in $) in Seychelles in 2003 to that in 2004?
Make the answer very short. 0.92. What is the ratio of the Taxes (in $) of Chile in 2003 to that in 2005?
Provide a succinct answer. 0.67. What is the ratio of the Taxes (in $) of Ethiopia in 2003 to that in 2005?
Ensure brevity in your answer.  0.72. What is the ratio of the Taxes (in $) in Italy in 2003 to that in 2005?
Provide a succinct answer. 0.97. What is the ratio of the Taxes (in $) in Seychelles in 2003 to that in 2005?
Keep it short and to the point. 0.9. What is the ratio of the Taxes (in $) in Chile in 2003 to that in 2006?
Your answer should be very brief. 0.52. What is the ratio of the Taxes (in $) in Ethiopia in 2003 to that in 2006?
Provide a short and direct response. 0.62. What is the ratio of the Taxes (in $) in Italy in 2003 to that in 2006?
Ensure brevity in your answer.  0.87. What is the ratio of the Taxes (in $) in Seychelles in 2003 to that in 2006?
Give a very brief answer. 0.9. What is the ratio of the Taxes (in $) of Chile in 2003 to that in 2007?
Provide a succinct answer. 0.45. What is the ratio of the Taxes (in $) of Ethiopia in 2003 to that in 2007?
Your response must be concise. 0.5. What is the ratio of the Taxes (in $) in Italy in 2003 to that in 2007?
Your response must be concise. 0.83. What is the ratio of the Taxes (in $) of Seychelles in 2003 to that in 2007?
Your response must be concise. 0.77. What is the ratio of the Taxes (in $) of Chile in 2003 to that in 2008?
Keep it short and to the point. 0.47. What is the ratio of the Taxes (in $) of Ethiopia in 2003 to that in 2008?
Your answer should be compact. 0.34. What is the ratio of the Taxes (in $) of Italy in 2003 to that in 2008?
Provide a succinct answer. 0.84. What is the ratio of the Taxes (in $) of Seychelles in 2003 to that in 2008?
Make the answer very short. 0.61. What is the ratio of the Taxes (in $) of Chile in 2004 to that in 2005?
Keep it short and to the point. 0.8. What is the ratio of the Taxes (in $) of Ethiopia in 2004 to that in 2005?
Offer a very short reply. 0.9. What is the ratio of the Taxes (in $) in Italy in 2004 to that in 2005?
Offer a very short reply. 0.99. What is the ratio of the Taxes (in $) of Seychelles in 2004 to that in 2005?
Make the answer very short. 0.99. What is the ratio of the Taxes (in $) in Chile in 2004 to that in 2006?
Your answer should be compact. 0.62. What is the ratio of the Taxes (in $) of Ethiopia in 2004 to that in 2006?
Offer a terse response. 0.77. What is the ratio of the Taxes (in $) in Italy in 2004 to that in 2006?
Your answer should be very brief. 0.89. What is the ratio of the Taxes (in $) in Seychelles in 2004 to that in 2006?
Give a very brief answer. 0.98. What is the ratio of the Taxes (in $) of Chile in 2004 to that in 2007?
Your answer should be very brief. 0.54. What is the ratio of the Taxes (in $) in Ethiopia in 2004 to that in 2007?
Give a very brief answer. 0.62. What is the ratio of the Taxes (in $) in Italy in 2004 to that in 2007?
Provide a succinct answer. 0.84. What is the ratio of the Taxes (in $) of Seychelles in 2004 to that in 2007?
Keep it short and to the point. 0.85. What is the ratio of the Taxes (in $) in Chile in 2004 to that in 2008?
Your answer should be compact. 0.56. What is the ratio of the Taxes (in $) in Ethiopia in 2004 to that in 2008?
Provide a short and direct response. 0.43. What is the ratio of the Taxes (in $) in Italy in 2004 to that in 2008?
Your answer should be very brief. 0.85. What is the ratio of the Taxes (in $) in Seychelles in 2004 to that in 2008?
Provide a short and direct response. 0.67. What is the ratio of the Taxes (in $) in Chile in 2005 to that in 2006?
Your answer should be very brief. 0.78. What is the ratio of the Taxes (in $) in Ethiopia in 2005 to that in 2006?
Give a very brief answer. 0.85. What is the ratio of the Taxes (in $) of Italy in 2005 to that in 2006?
Provide a succinct answer. 0.9. What is the ratio of the Taxes (in $) in Chile in 2005 to that in 2007?
Keep it short and to the point. 0.68. What is the ratio of the Taxes (in $) in Ethiopia in 2005 to that in 2007?
Give a very brief answer. 0.69. What is the ratio of the Taxes (in $) of Italy in 2005 to that in 2007?
Your response must be concise. 0.85. What is the ratio of the Taxes (in $) of Seychelles in 2005 to that in 2007?
Your answer should be very brief. 0.86. What is the ratio of the Taxes (in $) of Chile in 2005 to that in 2008?
Ensure brevity in your answer.  0.71. What is the ratio of the Taxes (in $) of Ethiopia in 2005 to that in 2008?
Ensure brevity in your answer.  0.48. What is the ratio of the Taxes (in $) of Italy in 2005 to that in 2008?
Provide a succinct answer. 0.86. What is the ratio of the Taxes (in $) of Seychelles in 2005 to that in 2008?
Provide a succinct answer. 0.67. What is the ratio of the Taxes (in $) of Chile in 2006 to that in 2007?
Your response must be concise. 0.87. What is the ratio of the Taxes (in $) of Ethiopia in 2006 to that in 2007?
Offer a terse response. 0.81. What is the ratio of the Taxes (in $) in Italy in 2006 to that in 2007?
Your answer should be compact. 0.95. What is the ratio of the Taxes (in $) in Seychelles in 2006 to that in 2007?
Make the answer very short. 0.86. What is the ratio of the Taxes (in $) in Chile in 2006 to that in 2008?
Give a very brief answer. 0.91. What is the ratio of the Taxes (in $) in Ethiopia in 2006 to that in 2008?
Your answer should be compact. 0.56. What is the ratio of the Taxes (in $) of Italy in 2006 to that in 2008?
Provide a succinct answer. 0.96. What is the ratio of the Taxes (in $) in Seychelles in 2006 to that in 2008?
Your answer should be compact. 0.68. What is the ratio of the Taxes (in $) of Chile in 2007 to that in 2008?
Your response must be concise. 1.05. What is the ratio of the Taxes (in $) in Ethiopia in 2007 to that in 2008?
Provide a short and direct response. 0.69. What is the ratio of the Taxes (in $) of Seychelles in 2007 to that in 2008?
Offer a very short reply. 0.79. What is the difference between the highest and the second highest Taxes (in $) of Chile?
Give a very brief answer. 8.12e+11. What is the difference between the highest and the second highest Taxes (in $) in Ethiopia?
Your response must be concise. 6.01e+09. What is the difference between the highest and the second highest Taxes (in $) in Italy?
Offer a very short reply. 3.18e+09. What is the difference between the highest and the second highest Taxes (in $) of Seychelles?
Keep it short and to the point. 4.36e+08. What is the difference between the highest and the lowest Taxes (in $) of Chile?
Your response must be concise. 1.06e+13. What is the difference between the highest and the lowest Taxes (in $) of Ethiopia?
Keep it short and to the point. 1.30e+1. What is the difference between the highest and the lowest Taxes (in $) of Italy?
Provide a short and direct response. 7.00e+1. What is the difference between the highest and the lowest Taxes (in $) of Seychelles?
Make the answer very short. 1.05e+09. 